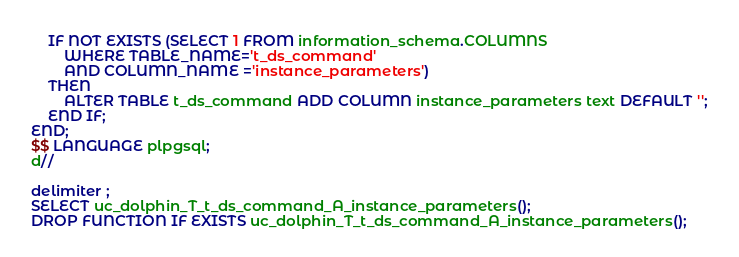Convert code to text. <code><loc_0><loc_0><loc_500><loc_500><_SQL_>    IF NOT EXISTS (SELECT 1 FROM information_schema.COLUMNS
        WHERE TABLE_NAME='t_ds_command'
        AND COLUMN_NAME ='instance_parameters')
    THEN
        ALTER TABLE t_ds_command ADD COLUMN instance_parameters text DEFAULT '';
    END IF;
END;
$$ LANGUAGE plpgsql;
d//

delimiter ;
SELECT uc_dolphin_T_t_ds_command_A_instance_parameters();
DROP FUNCTION IF EXISTS uc_dolphin_T_t_ds_command_A_instance_parameters();</code> 